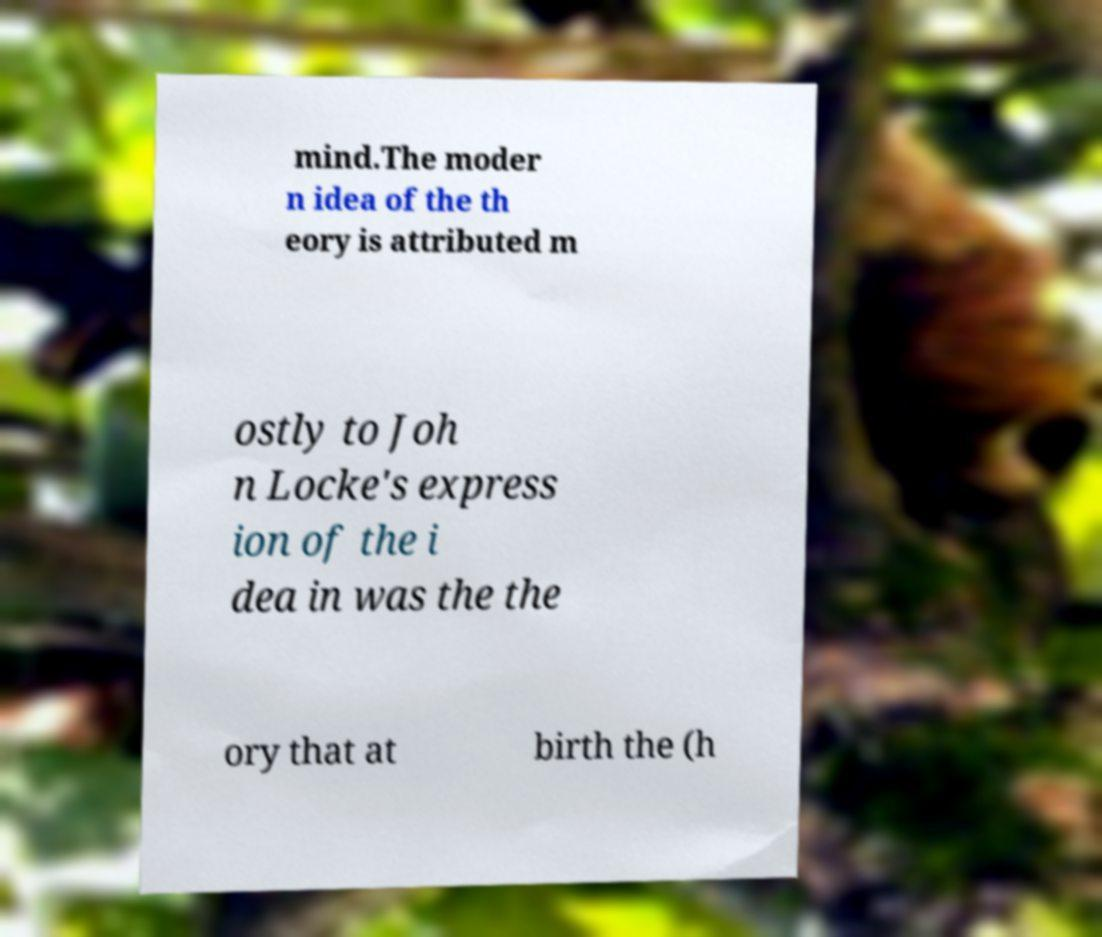Could you extract and type out the text from this image? mind.The moder n idea of the th eory is attributed m ostly to Joh n Locke's express ion of the i dea in was the the ory that at birth the (h 